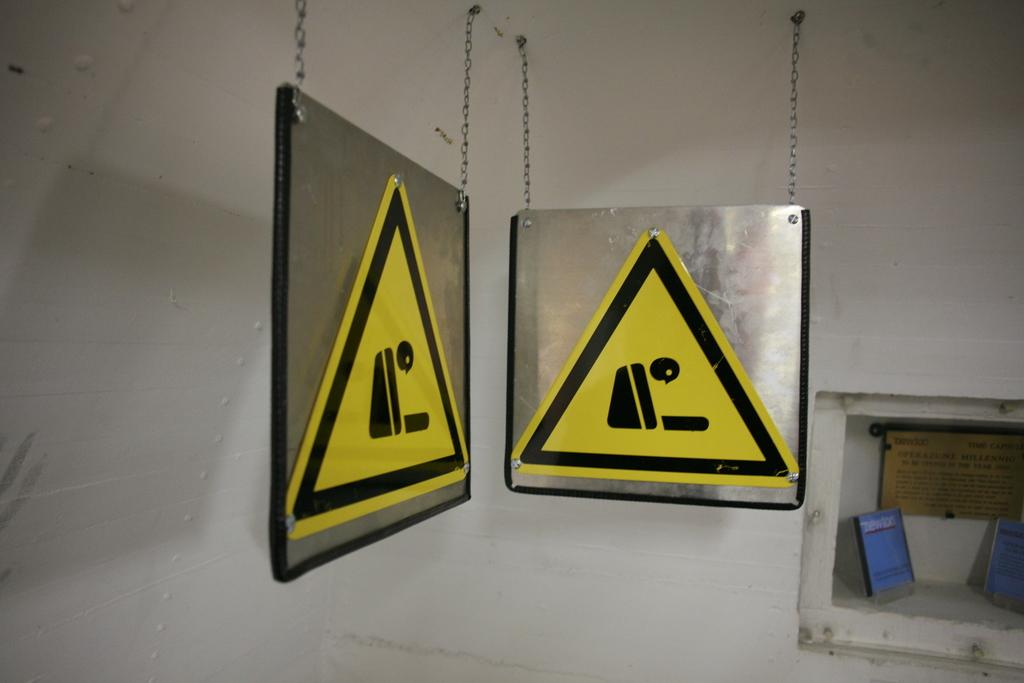What can be seen hanging from the ceiling in the image? There are two boards with signs in the image, and they are hung with chains. What is located on the right side of the image? There is a wall with a box on the right side of the image. What is inside the box? There are items inside the box. What type of competition is taking place in the image? There is no competition present in the image. Can you describe the tail of the animal in the image? There are no animals, including those with tails, present in the image. 